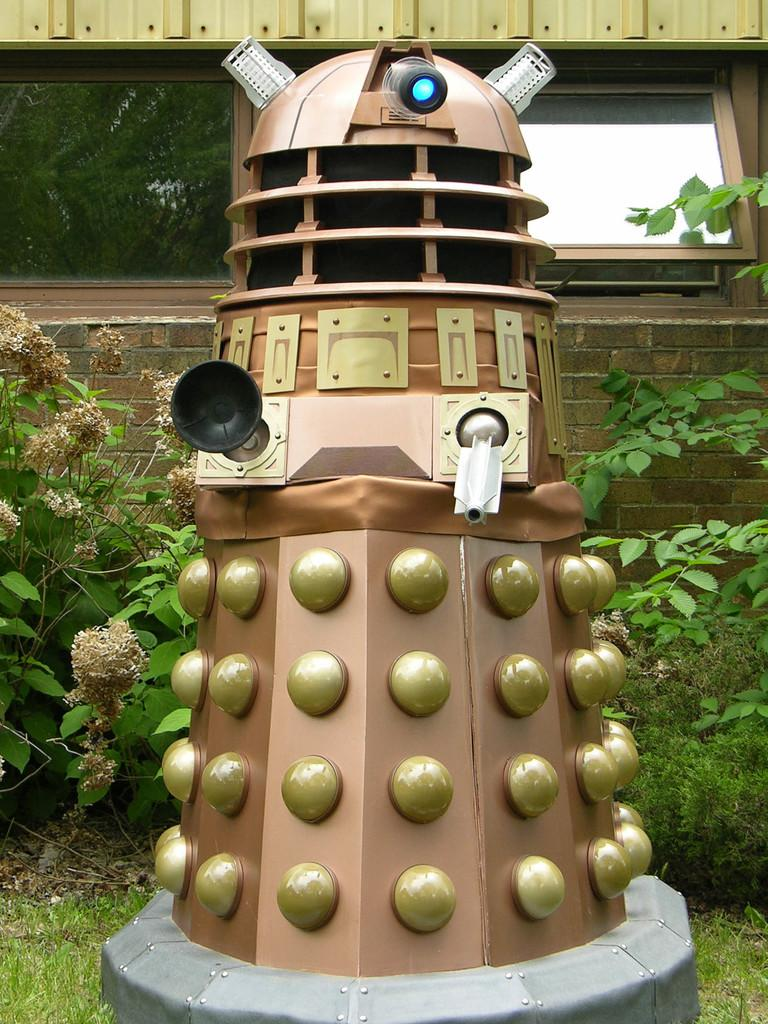What is the main subject in the image? There is a robot in the image. What feature does the robot have? The robot has lights. What can be seen near the robot? There are other objects near the robot. Where are the objects and the robot located? They are on the grass. What is the surface beneath the objects and the robot? The grass is on the ground. What can be seen in the background of the image? There are plants and a building with glass windows in the background of the image. How does the robot help the fireman in the image? There is no fireman present in the image, so the robot cannot help a fireman. 